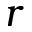Convert formula to latex. <formula><loc_0><loc_0><loc_500><loc_500>r</formula> 